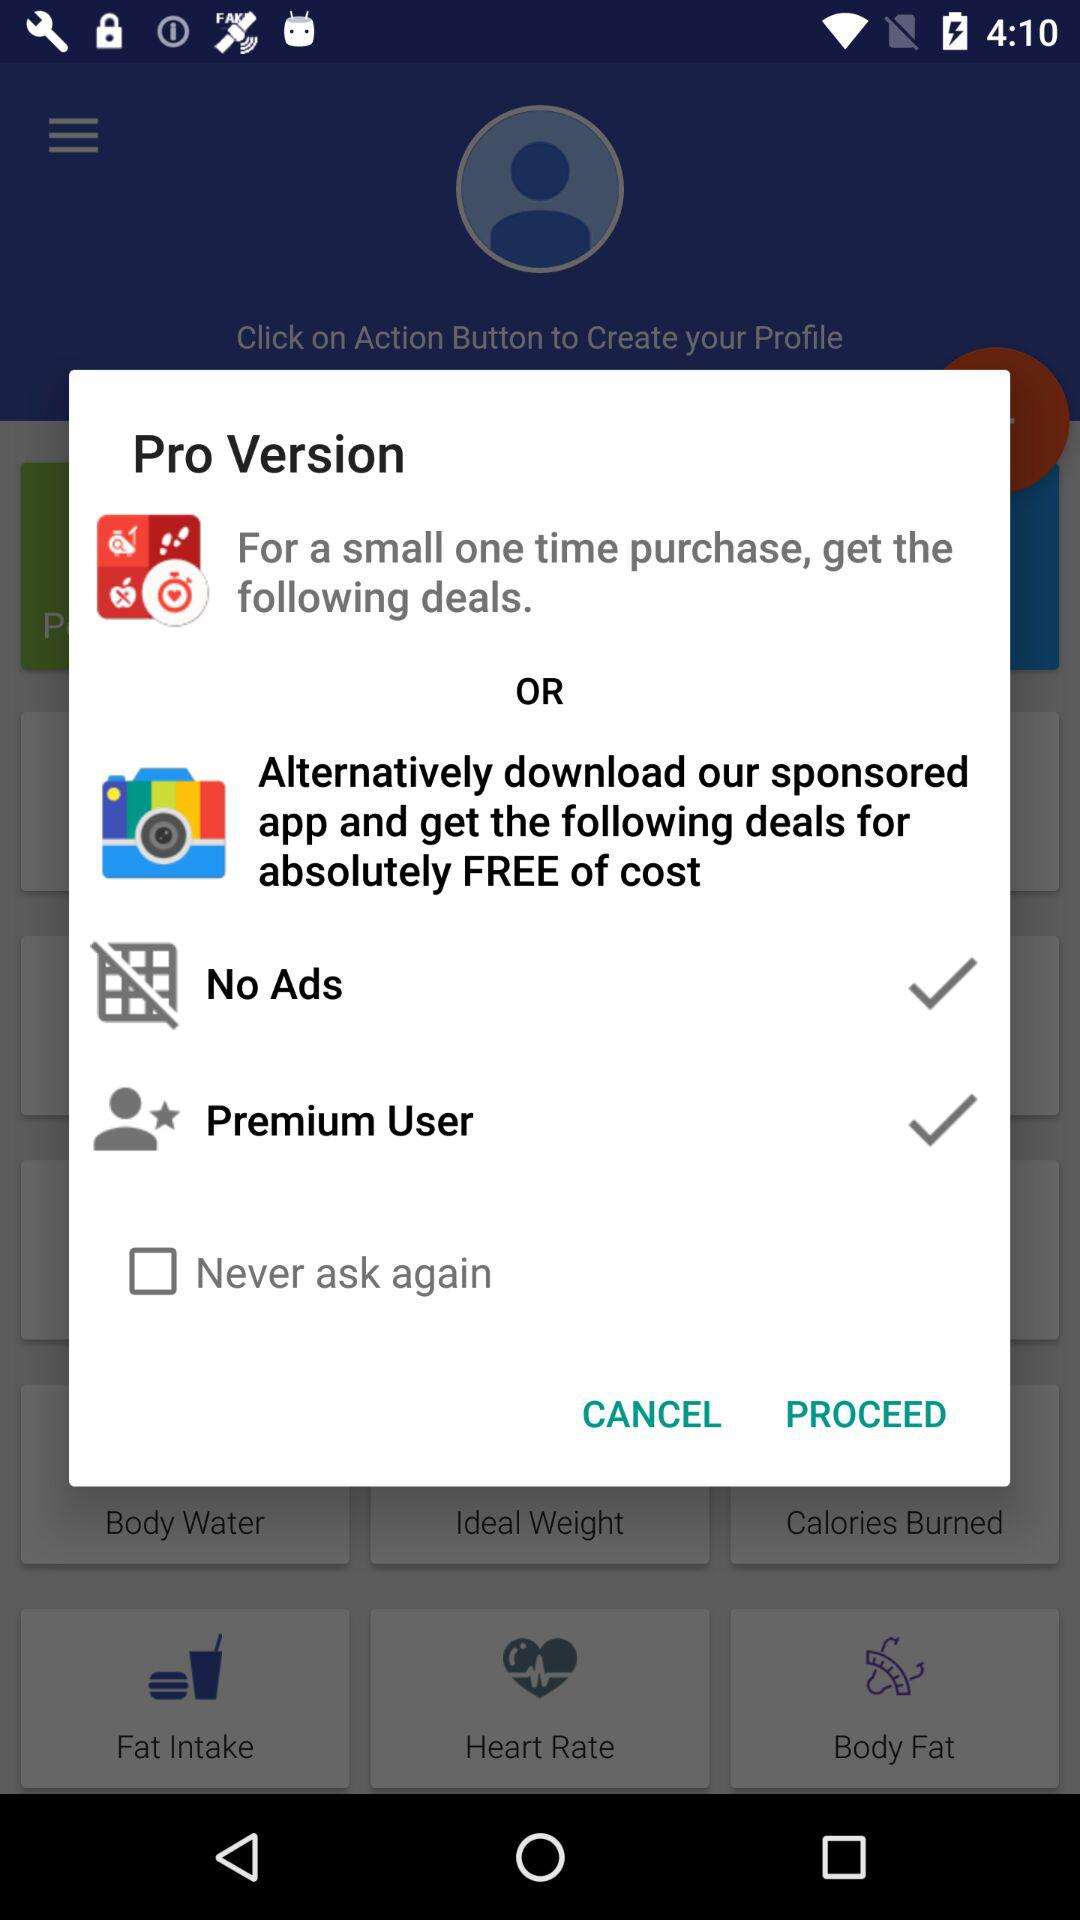What is the status of "Never ask again"? The status of "Never ask again" is "off". 